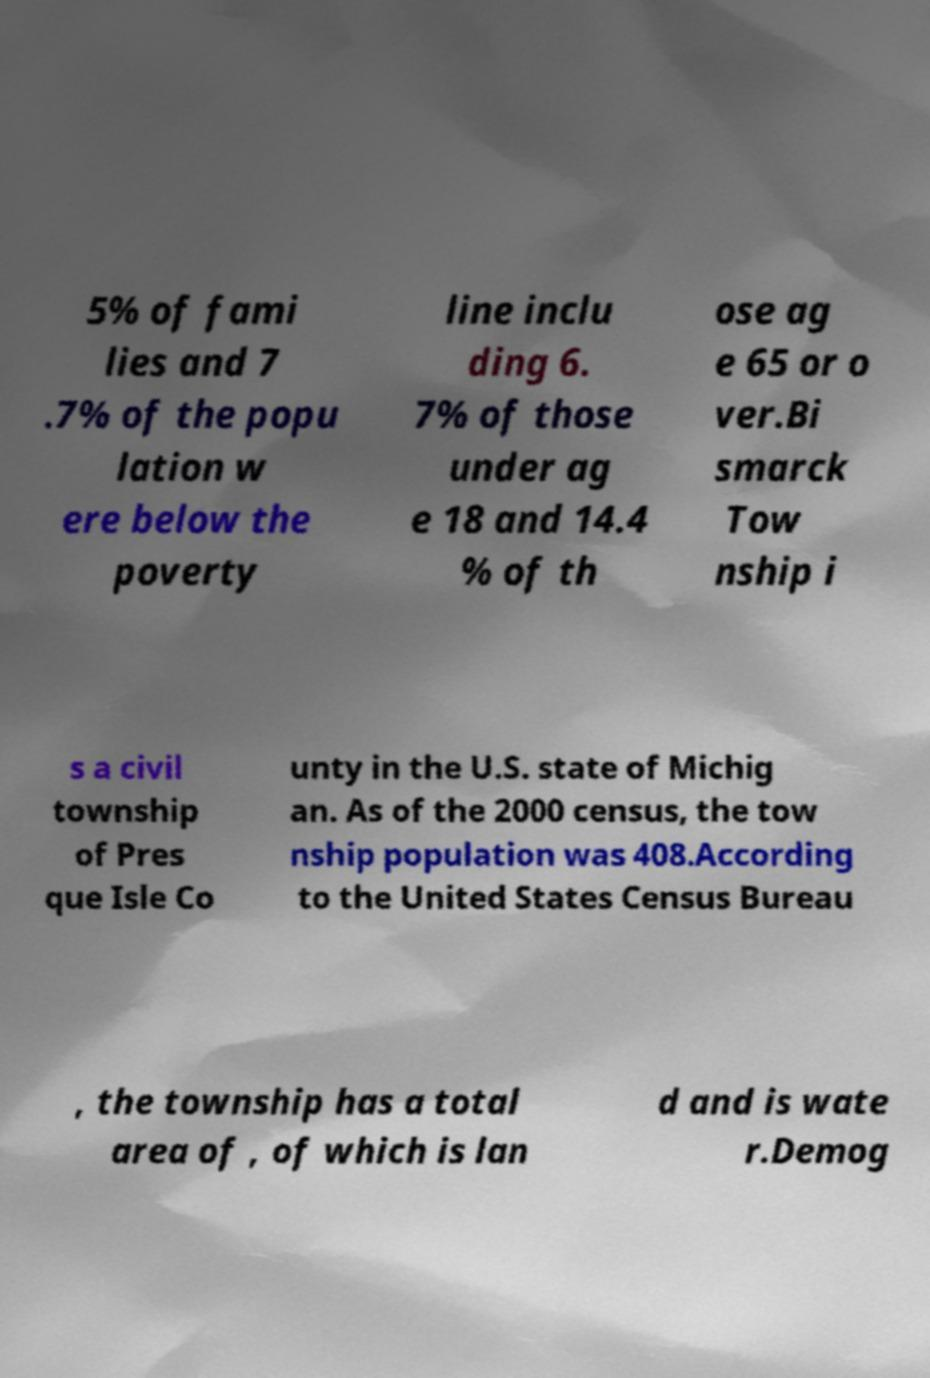For documentation purposes, I need the text within this image transcribed. Could you provide that? 5% of fami lies and 7 .7% of the popu lation w ere below the poverty line inclu ding 6. 7% of those under ag e 18 and 14.4 % of th ose ag e 65 or o ver.Bi smarck Tow nship i s a civil township of Pres que Isle Co unty in the U.S. state of Michig an. As of the 2000 census, the tow nship population was 408.According to the United States Census Bureau , the township has a total area of , of which is lan d and is wate r.Demog 